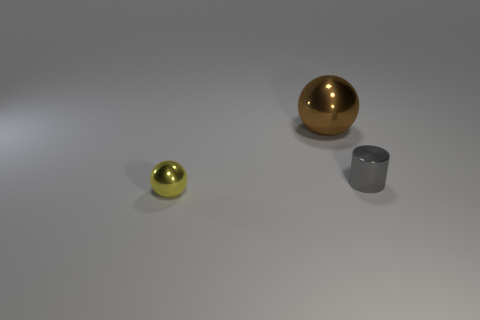Is there anything else that is the same size as the brown shiny sphere?
Make the answer very short. No. Does the brown sphere have the same material as the gray cylinder?
Give a very brief answer. Yes. How many tiny yellow balls are to the left of the yellow sphere?
Provide a succinct answer. 0. There is a object that is both to the left of the metallic cylinder and behind the small yellow object; what is its material?
Keep it short and to the point. Metal. What number of yellow spheres have the same size as the brown sphere?
Offer a terse response. 0. What is the color of the sphere that is in front of the metallic thing behind the gray cylinder?
Make the answer very short. Yellow. Are there any small brown cylinders?
Ensure brevity in your answer.  No. Is the brown shiny object the same shape as the tiny yellow metallic object?
Offer a very short reply. Yes. There is a tiny shiny object that is in front of the small gray cylinder; how many things are to the right of it?
Make the answer very short. 2. What number of metal objects are behind the yellow thing and in front of the big metal thing?
Your response must be concise. 1. 